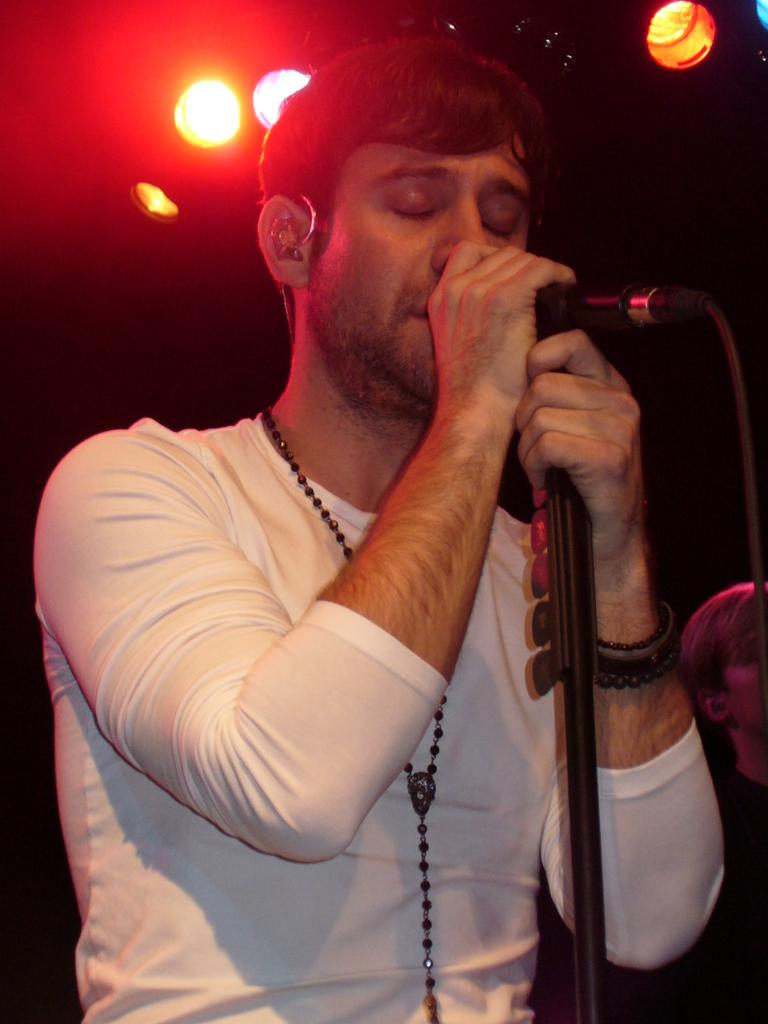How many people are present in the image? There are two people in the image. What is the man holding in the image? The man is holding a mic in the image. What can be seen in the background of the image? There are lights visible in the background of the image. How would you describe the lighting conditions in the image? The setting is dark. What type of sticks are being used by the people in the image? There are no sticks visible in the image. Can you tell me how many bones are present in the image? There are no bones present in the image. 